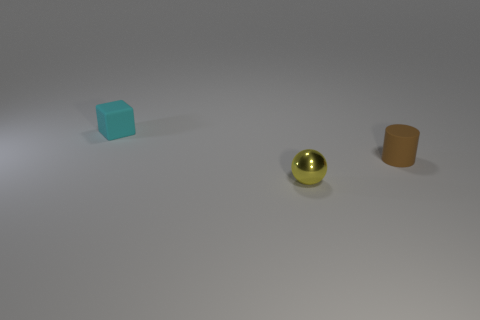Can you describe the spatial arrangement of the three objects in the image? Certainly! In the image, three objects are arranged from left to right with enough space between them to be distinct. On the far left, there is a small, matte blue cube. Centered in the image is a small, shiny yellow sphere. And to the right, there's a small matte orange cylinder. The placement creates a visually interesting trio with varying shapes, colors, and textures. 